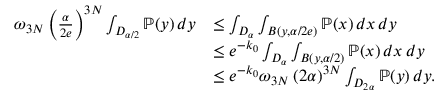<formula> <loc_0><loc_0><loc_500><loc_500>\begin{array} { r l } { \omega _ { 3 N } \left ( \frac { \alpha } { 2 e } \right ) ^ { 3 N } \int _ { D _ { \alpha / 2 } } \mathbb { P } ( y ) \, d y } & { \leq \int _ { D _ { \alpha } } \int _ { B ( y , \alpha / 2 e ) } \mathbb { P } ( x ) \, d x \, d y } \\ & { \leq e ^ { - k _ { 0 } } \int _ { D _ { \alpha } } \int _ { B ( y , \alpha / 2 ) } \mathbb { P } ( x ) \, d x \, d y } \\ & { \leq e ^ { - k _ { 0 } } \omega _ { 3 N } \left ( 2 \alpha \right ) ^ { 3 N } \int _ { D _ { 2 \alpha } } \mathbb { P } ( y ) \, d y . } \end{array}</formula> 